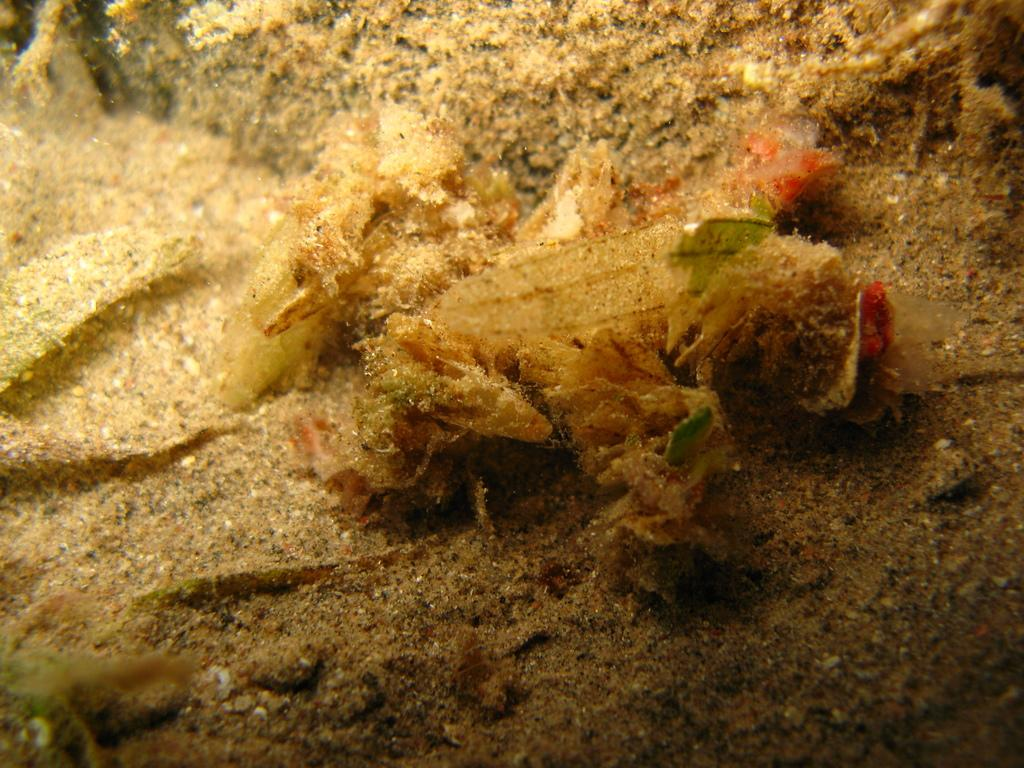What type of creature can be seen in the image? There is an underwater creature in the image. What is the environment like in the image? The environment includes sand, which suggests a beach or underwater setting. What type of meat is being served at the vacation spot in the image? There is no information about meat or a vacation spot in the image; it only features an underwater creature and sand. 